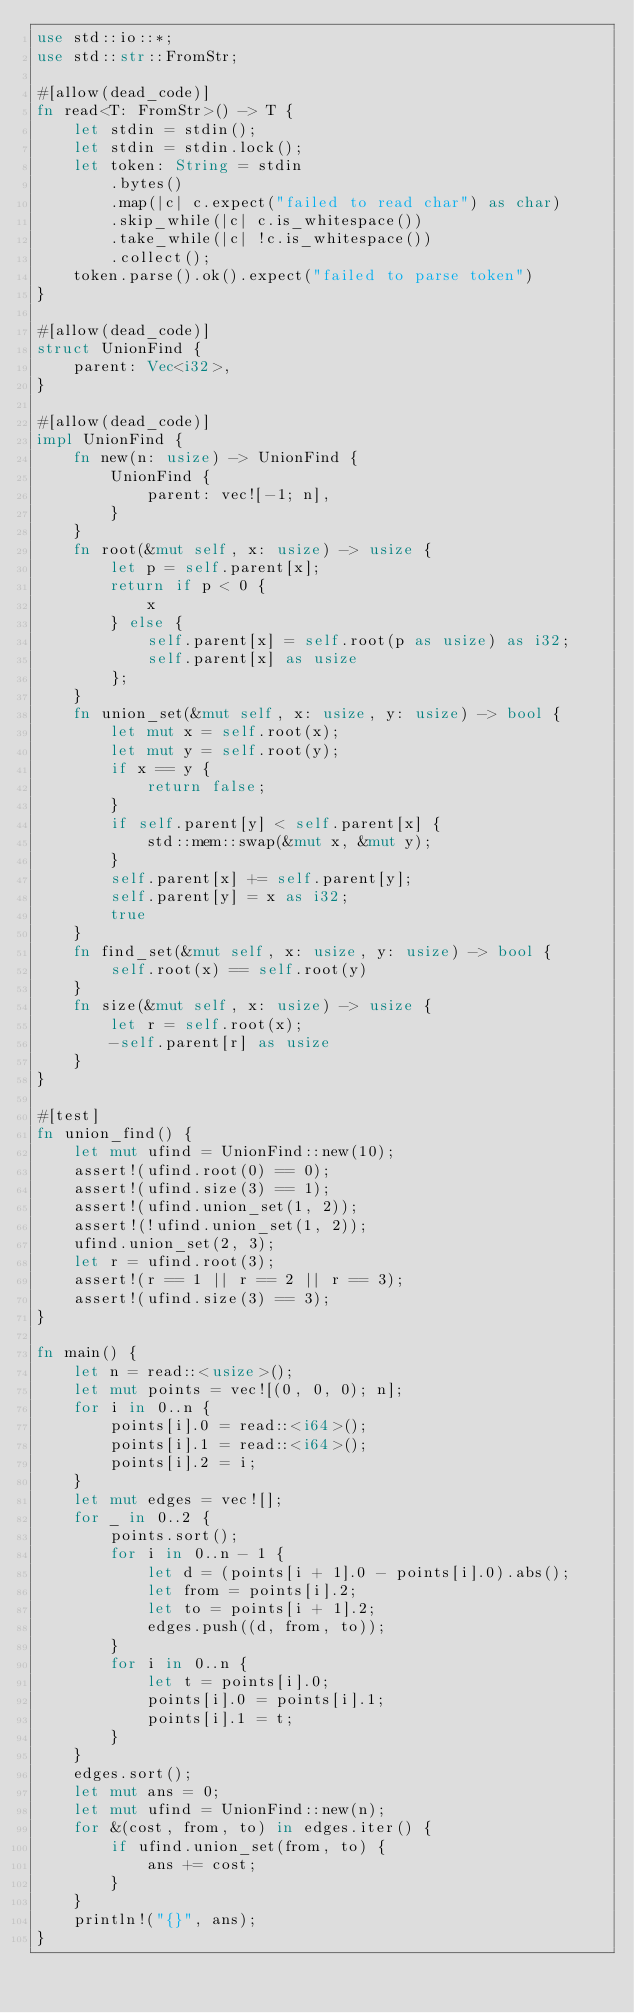Convert code to text. <code><loc_0><loc_0><loc_500><loc_500><_Rust_>use std::io::*;
use std::str::FromStr;

#[allow(dead_code)]
fn read<T: FromStr>() -> T {
    let stdin = stdin();
    let stdin = stdin.lock();
    let token: String = stdin
        .bytes()
        .map(|c| c.expect("failed to read char") as char)
        .skip_while(|c| c.is_whitespace())
        .take_while(|c| !c.is_whitespace())
        .collect();
    token.parse().ok().expect("failed to parse token")
}

#[allow(dead_code)]
struct UnionFind {
    parent: Vec<i32>,
}

#[allow(dead_code)]
impl UnionFind {
    fn new(n: usize) -> UnionFind {
        UnionFind {
            parent: vec![-1; n],
        }
    }
    fn root(&mut self, x: usize) -> usize {
        let p = self.parent[x];
        return if p < 0 {
            x
        } else {
            self.parent[x] = self.root(p as usize) as i32;
            self.parent[x] as usize
        };
    }
    fn union_set(&mut self, x: usize, y: usize) -> bool {
        let mut x = self.root(x);
        let mut y = self.root(y);
        if x == y {
            return false;
        }
        if self.parent[y] < self.parent[x] {
            std::mem::swap(&mut x, &mut y);
        }
        self.parent[x] += self.parent[y];
        self.parent[y] = x as i32;
        true
    }
    fn find_set(&mut self, x: usize, y: usize) -> bool {
        self.root(x) == self.root(y)
    }
    fn size(&mut self, x: usize) -> usize {
        let r = self.root(x);
        -self.parent[r] as usize
    }
}

#[test]
fn union_find() {
    let mut ufind = UnionFind::new(10);
    assert!(ufind.root(0) == 0);
    assert!(ufind.size(3) == 1);
    assert!(ufind.union_set(1, 2));
    assert!(!ufind.union_set(1, 2));
    ufind.union_set(2, 3);
    let r = ufind.root(3);
    assert!(r == 1 || r == 2 || r == 3);
    assert!(ufind.size(3) == 3);
}

fn main() {
    let n = read::<usize>();
    let mut points = vec![(0, 0, 0); n];
    for i in 0..n {
        points[i].0 = read::<i64>();
        points[i].1 = read::<i64>();
        points[i].2 = i;
    }
    let mut edges = vec![];
    for _ in 0..2 {
        points.sort();
        for i in 0..n - 1 {
            let d = (points[i + 1].0 - points[i].0).abs();
            let from = points[i].2;
            let to = points[i + 1].2;
            edges.push((d, from, to));
        }
        for i in 0..n {
            let t = points[i].0;
            points[i].0 = points[i].1;
            points[i].1 = t;
        }
    }
    edges.sort();
    let mut ans = 0;
    let mut ufind = UnionFind::new(n);
    for &(cost, from, to) in edges.iter() {
        if ufind.union_set(from, to) {
            ans += cost;
        }
    }
    println!("{}", ans);
}
</code> 